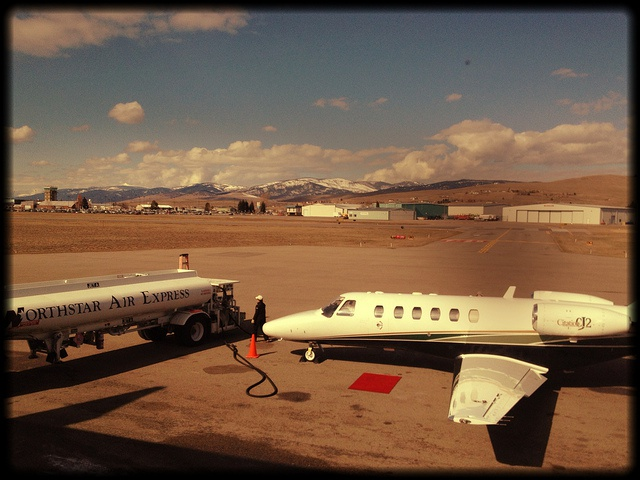Describe the objects in this image and their specific colors. I can see airplane in black, khaki, and tan tones, truck in black, maroon, gray, and khaki tones, and people in black, maroon, tan, and khaki tones in this image. 